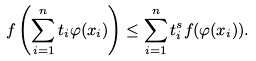<formula> <loc_0><loc_0><loc_500><loc_500>f \left ( \sum _ { i = 1 } ^ { n } t _ { i } \varphi ( x _ { i } ) \right ) \leq \sum _ { i = 1 } ^ { n } t _ { i } ^ { s } f ( \varphi ( x _ { i } ) ) .</formula> 